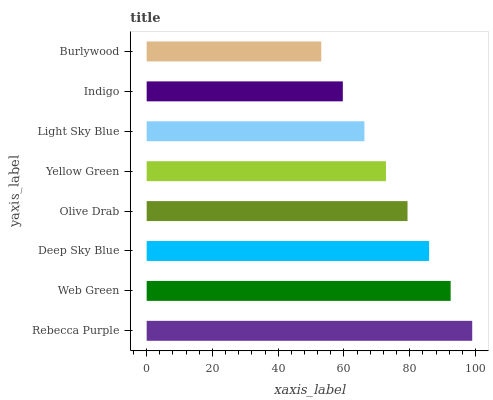Is Burlywood the minimum?
Answer yes or no. Yes. Is Rebecca Purple the maximum?
Answer yes or no. Yes. Is Web Green the minimum?
Answer yes or no. No. Is Web Green the maximum?
Answer yes or no. No. Is Rebecca Purple greater than Web Green?
Answer yes or no. Yes. Is Web Green less than Rebecca Purple?
Answer yes or no. Yes. Is Web Green greater than Rebecca Purple?
Answer yes or no. No. Is Rebecca Purple less than Web Green?
Answer yes or no. No. Is Olive Drab the high median?
Answer yes or no. Yes. Is Yellow Green the low median?
Answer yes or no. Yes. Is Rebecca Purple the high median?
Answer yes or no. No. Is Indigo the low median?
Answer yes or no. No. 